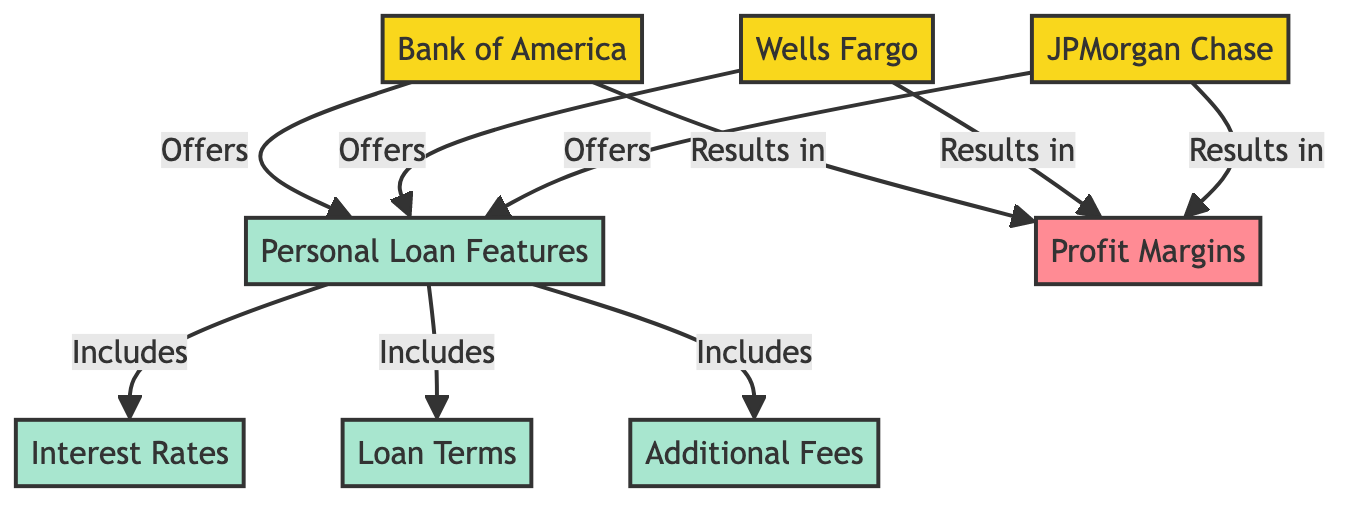What are the three banks depicted in the diagram? The diagram shows three banks: Bank of America, Wells Fargo, and JPMorgan Chase. These names are the labels on the respective nodes for each bank.
Answer: Bank of America, Wells Fargo, JPMorgan Chase How many personal loan features are listed in the diagram? The diagram highlights one node labeled "Personal Loan Features," which indicates that this represents a single categorization of features.
Answer: One What type of relationships exist between the banks and personal loan features? Each bank has a directed edge to the "Personal Loan Features" node, indicating that each bank offers these features. This is a one-way relationship from each bank to the features.
Answer: Offers Which bank leads to the highest profit margins? The diagram shows that each bank has a direct connection to the "Profit Margins" node, without any additional data to indicate which is the highest; hence, we can't infer which bank leads to higher profit margins based solely on the diagram.
Answer: Not determinable What specific aspects do personal loan features include according to the diagram? The diagram indicates that the "Personal Loan Features" node includes sub-nodes for "Interest Rates," "Loan Terms," and "Additional Fees," demonstrating the elements that comprise personal loan products.
Answer: Interest Rates, Loan Terms, Additional Fees If a bank offers diverse personal loan features, how might that influence its profit margins? The diagram implies that offering more attractive personal loan features could lead to better profit margins, as shown by each bank resulting in a connection to "Profit Margins." However, the impact isn't quantified in the diagram.
Answer: Higher profit margins (implied) How many features can be derived from "Product Features"? There are three features derived from "Product Features," which include Interest Rates, Loan Terms, and Additional Fees. These are directly linked from the Product Features node.
Answer: Three What is the visual representation style of the banks in the diagram? The banks are styled with a fill color of yellow (in hex #f9d71c) and a significant stroke width, making them prominent in the visual representation.
Answer: Yellow fill What shape classification do the banks belong to? The banks are represented in rounded rectangles, providing a distinctive shape that is consistent across all bank nodes.
Answer: Rounded rectangles 